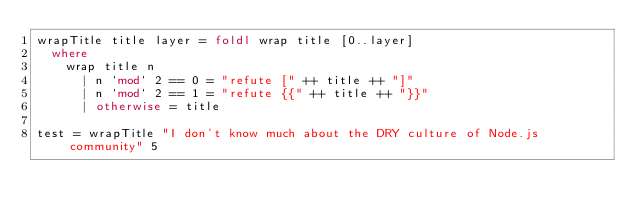Convert code to text. <code><loc_0><loc_0><loc_500><loc_500><_Haskell_>wrapTitle title layer = foldl wrap title [0..layer]
  where
    wrap title n
      | n `mod` 2 == 0 = "refute [" ++ title ++ "]"
      | n `mod` 2 == 1 = "refute {{" ++ title ++ "}}"
      | otherwise = title

test = wrapTitle "I don't know much about the DRY culture of Node.js community" 5



</code> 